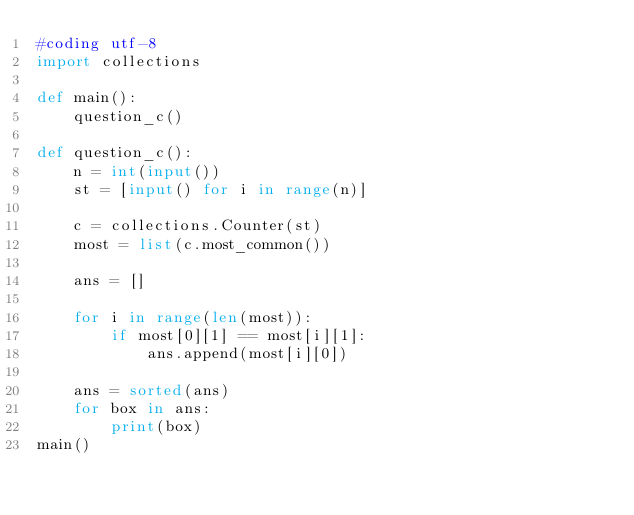<code> <loc_0><loc_0><loc_500><loc_500><_Python_>#coding utf-8
import collections

def main():
    question_c()

def question_c():
    n = int(input())
    st = [input() for i in range(n)]

    c = collections.Counter(st)
    most = list(c.most_common())

    ans = []

    for i in range(len(most)):
        if most[0][1] == most[i][1]:
            ans.append(most[i][0])

    ans = sorted(ans)
    for box in ans:
        print(box)
main()</code> 